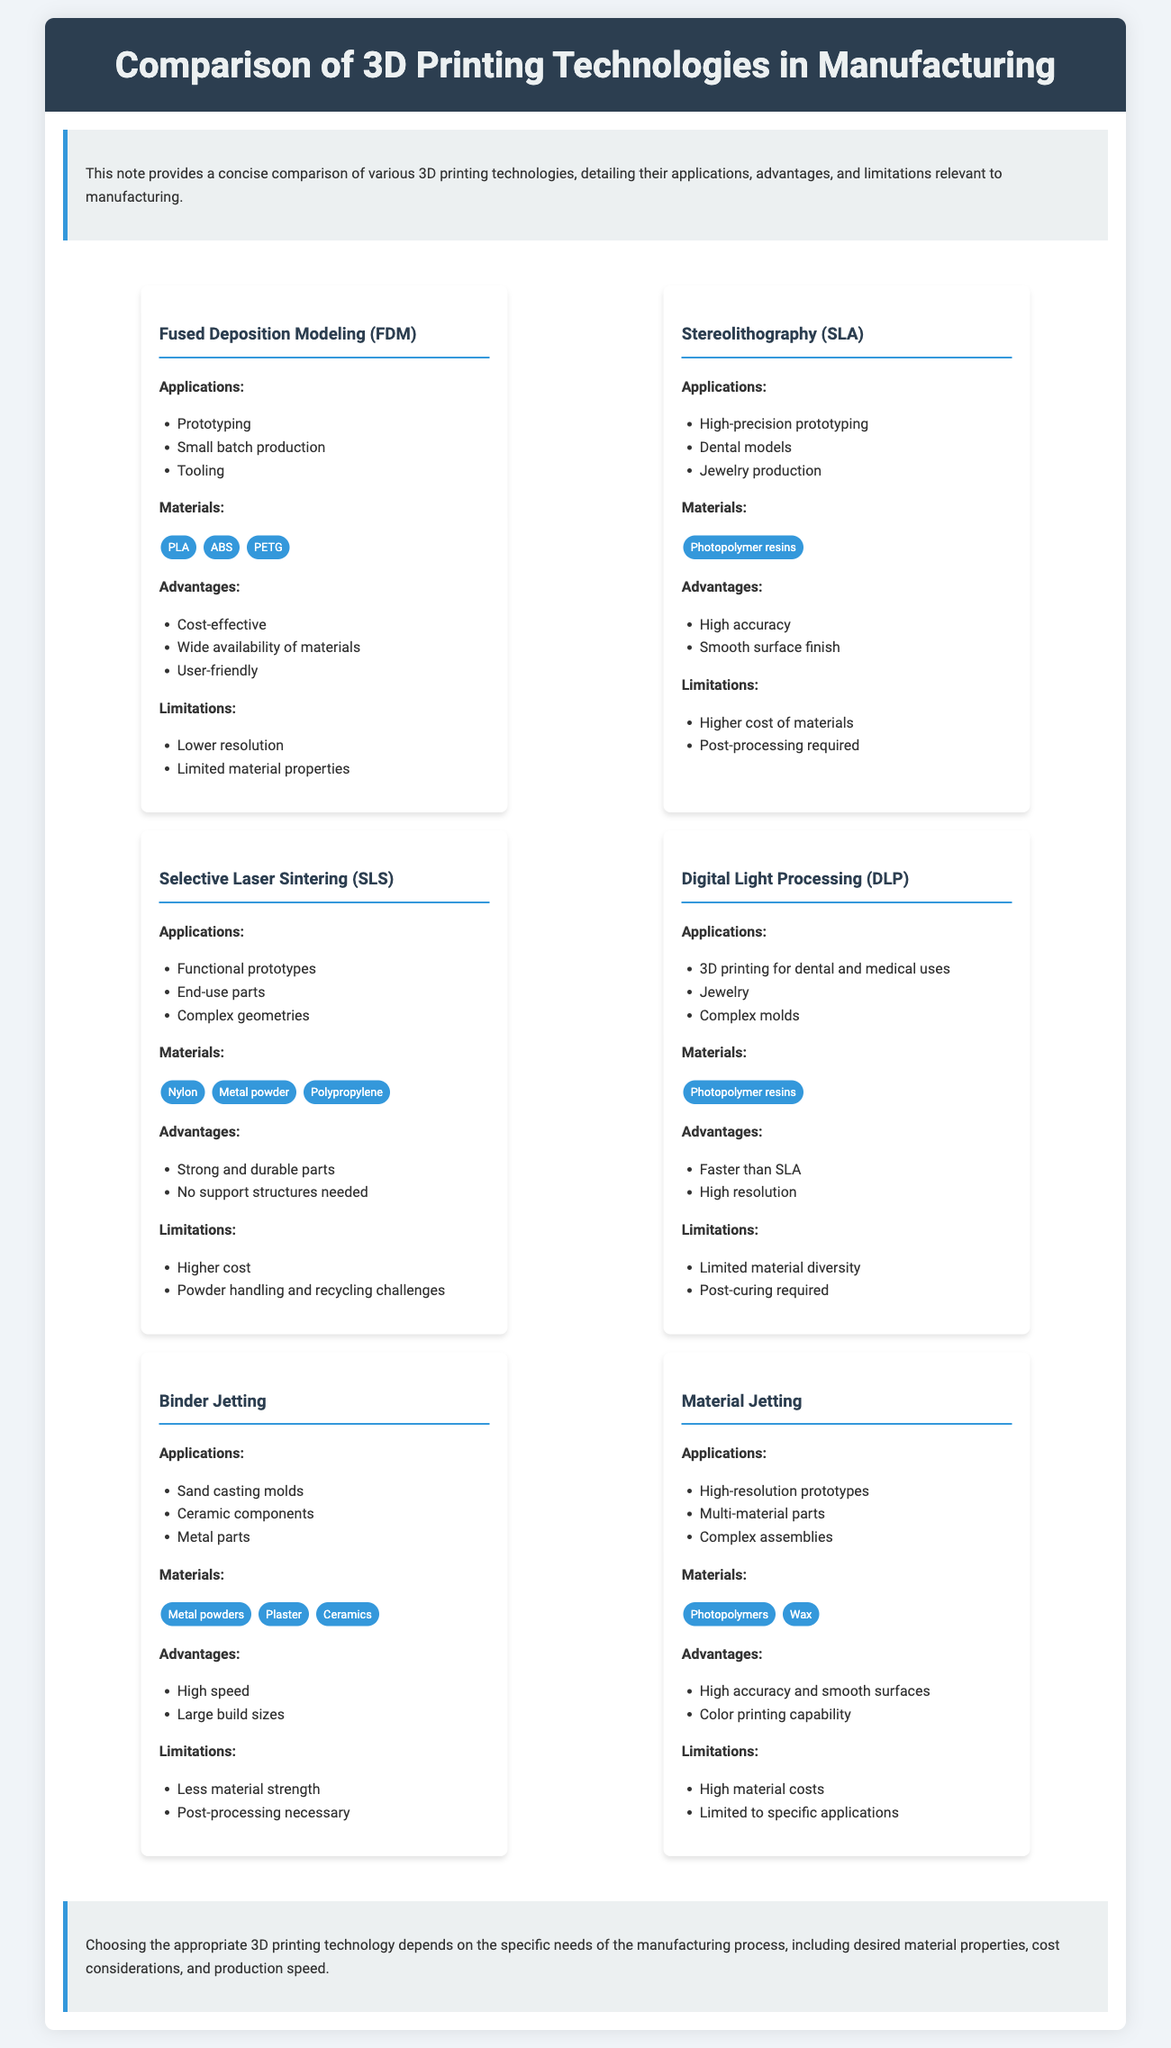What are the applications of Fused Deposition Modeling (FDM)? FDM is used for prototyping, small batch production, and tooling.
Answer: Prototyping, small batch production, tooling What materials are used in Selective Laser Sintering (SLS)? SLS commonly uses materials such as nylon, metal powder, and polypropylene.
Answer: Nylon, metal powder, polypropylene What is a limitation of Stereolithography (SLA)? One limitation of SLA is the higher cost of materials.
Answer: Higher cost of materials Which 3D printing technology is faster than SLA? Digital Light Processing (DLP) is faster than SLA.
Answer: Digital Light Processing (DLP) What are the advantages of Material Jetting? Material Jetting offers high accuracy and smooth surfaces, along with color printing capability.
Answer: High accuracy and smooth surfaces, color printing capability How many 3D printing technologies are listed in the document? The document lists a total of six 3D printing technologies.
Answer: Six What is a specific application of Binder Jetting? Binder Jetting can be used for sand casting molds.
Answer: Sand casting molds What is a common application for Digital Light Processing (DLP)? DLP is commonly used for dental and medical applications.
Answer: Dental and medical uses 